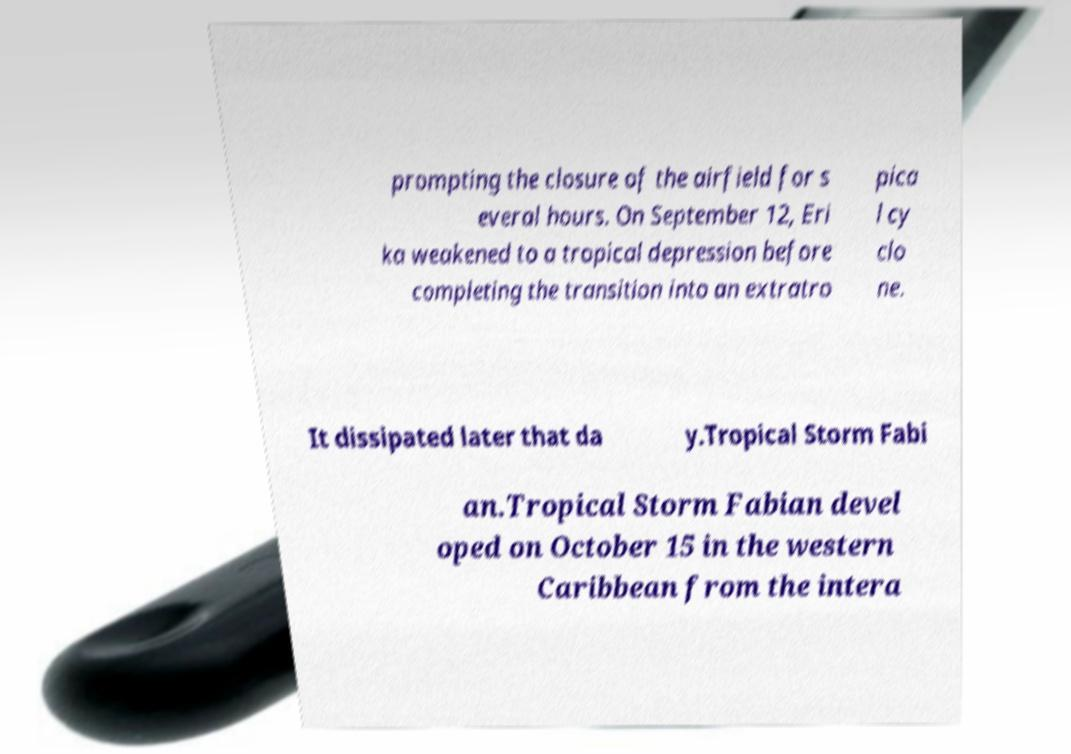There's text embedded in this image that I need extracted. Can you transcribe it verbatim? prompting the closure of the airfield for s everal hours. On September 12, Eri ka weakened to a tropical depression before completing the transition into an extratro pica l cy clo ne. It dissipated later that da y.Tropical Storm Fabi an.Tropical Storm Fabian devel oped on October 15 in the western Caribbean from the intera 